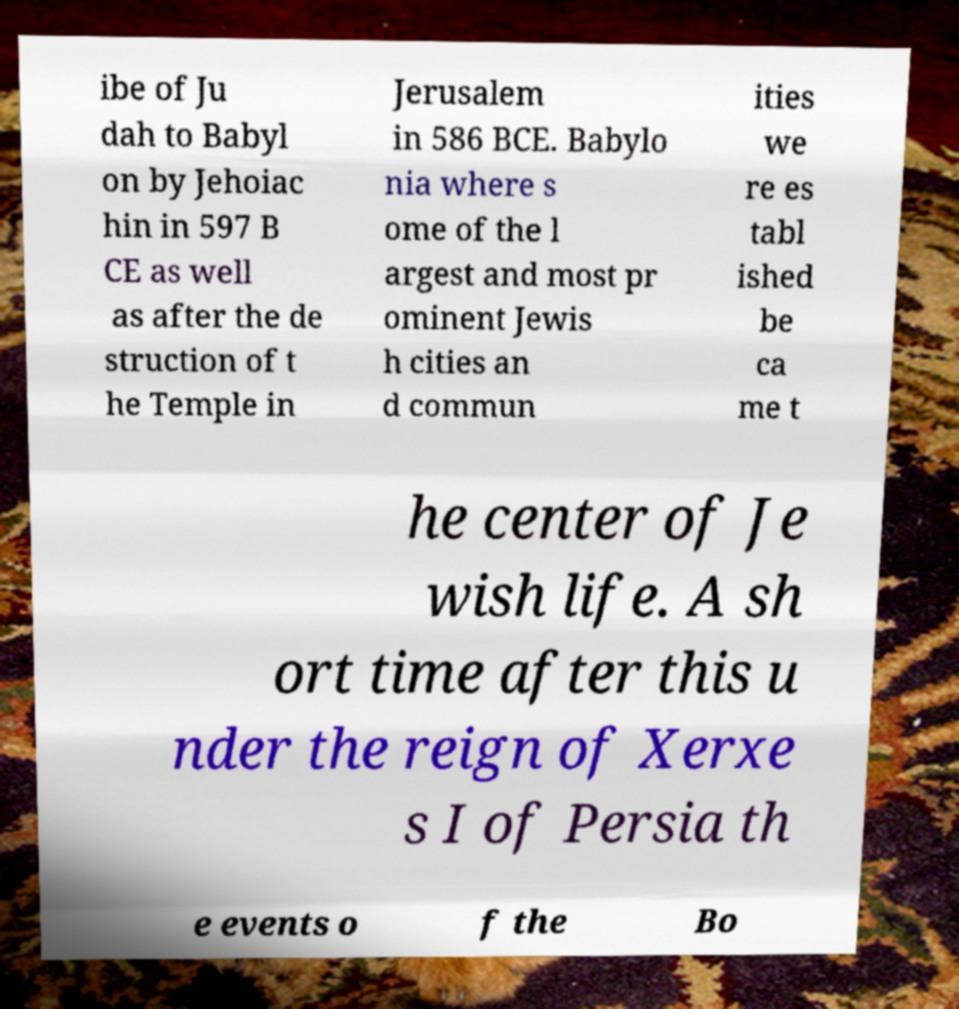Could you extract and type out the text from this image? ibe of Ju dah to Babyl on by Jehoiac hin in 597 B CE as well as after the de struction of t he Temple in Jerusalem in 586 BCE. Babylo nia where s ome of the l argest and most pr ominent Jewis h cities an d commun ities we re es tabl ished be ca me t he center of Je wish life. A sh ort time after this u nder the reign of Xerxe s I of Persia th e events o f the Bo 